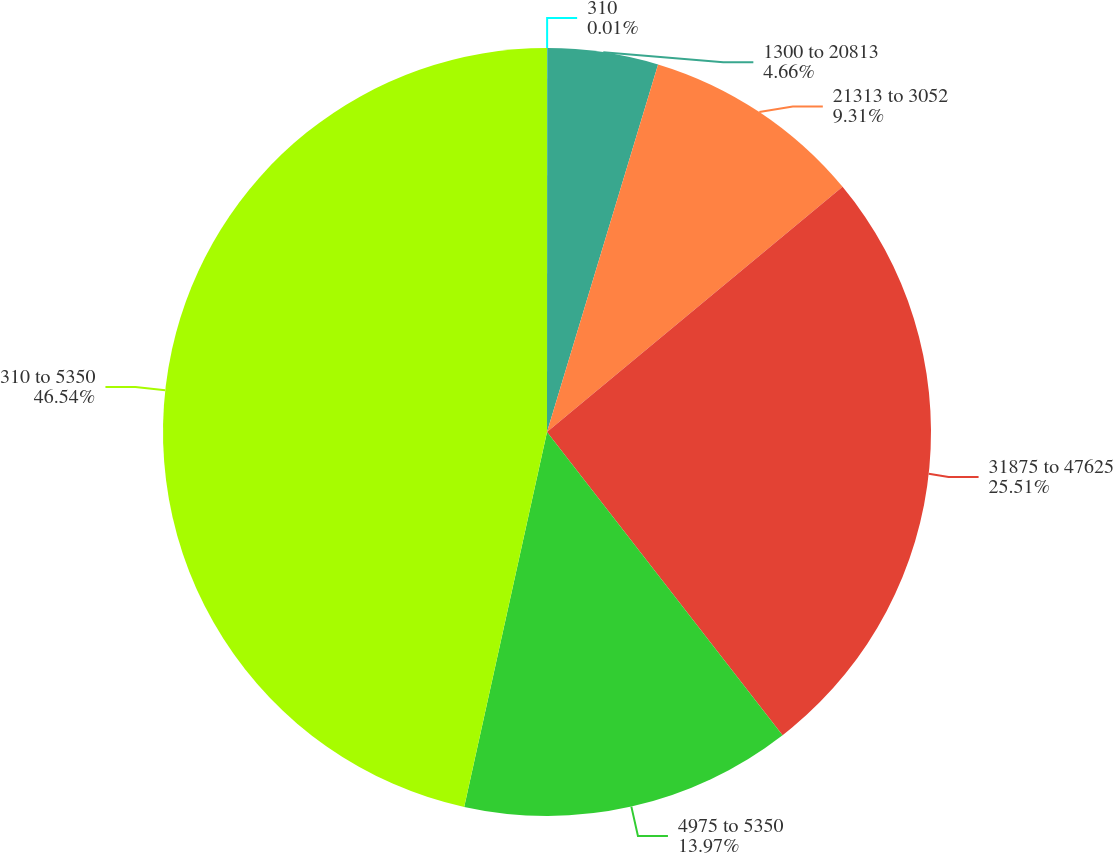<chart> <loc_0><loc_0><loc_500><loc_500><pie_chart><fcel>310<fcel>1300 to 20813<fcel>21313 to 3052<fcel>31875 to 47625<fcel>4975 to 5350<fcel>310 to 5350<nl><fcel>0.01%<fcel>4.66%<fcel>9.31%<fcel>25.51%<fcel>13.97%<fcel>46.54%<nl></chart> 